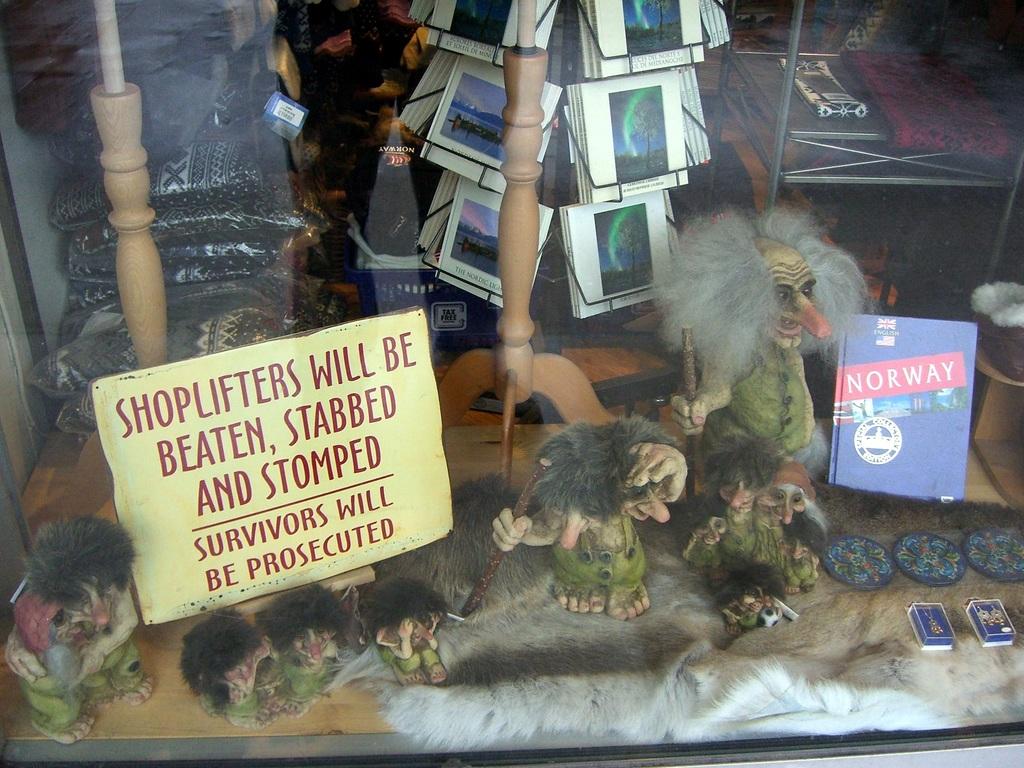What country is the window display advertising?
Your answer should be very brief. Norway. Who will be beaten?
Offer a terse response. Shoplifters. 